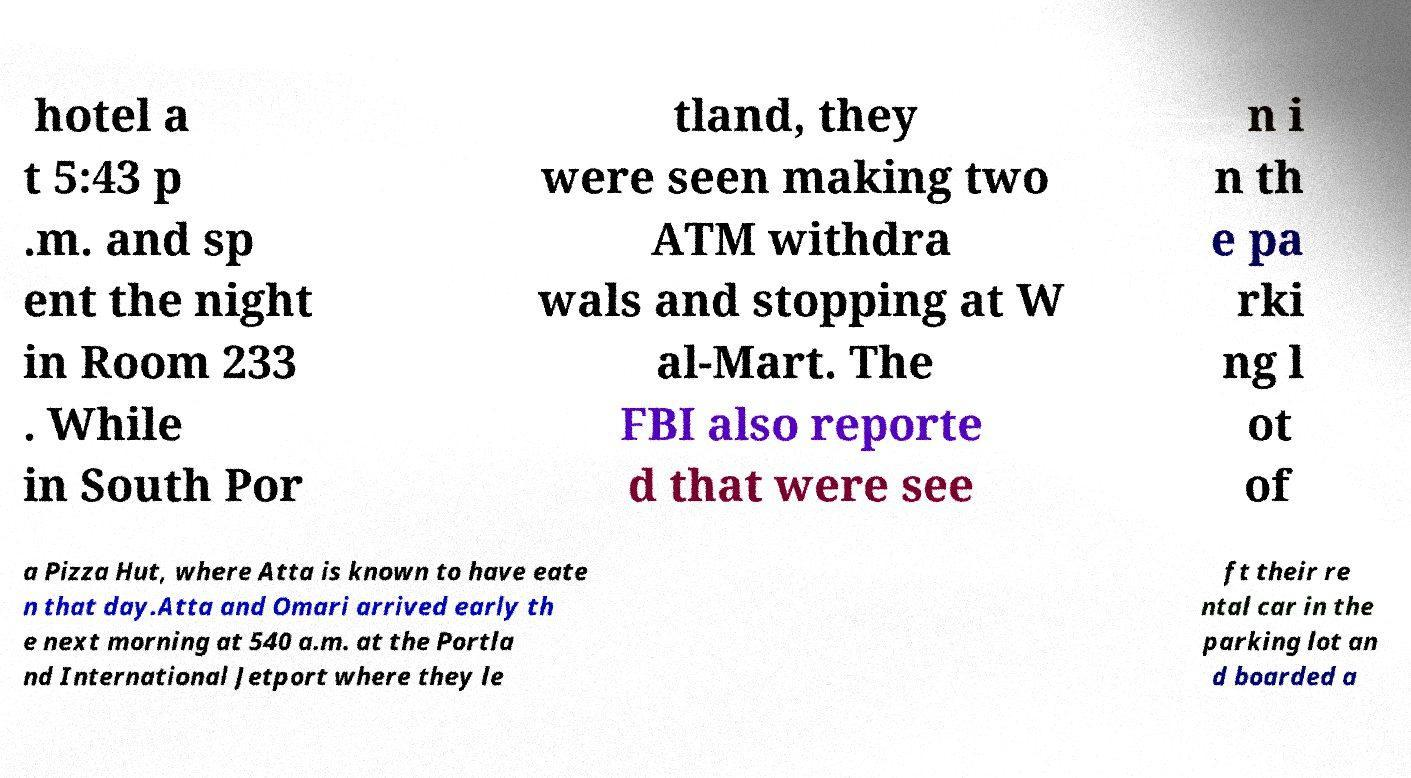There's text embedded in this image that I need extracted. Can you transcribe it verbatim? hotel a t 5:43 p .m. and sp ent the night in Room 233 . While in South Por tland, they were seen making two ATM withdra wals and stopping at W al-Mart. The FBI also reporte d that were see n i n th e pa rki ng l ot of a Pizza Hut, where Atta is known to have eate n that day.Atta and Omari arrived early th e next morning at 540 a.m. at the Portla nd International Jetport where they le ft their re ntal car in the parking lot an d boarded a 